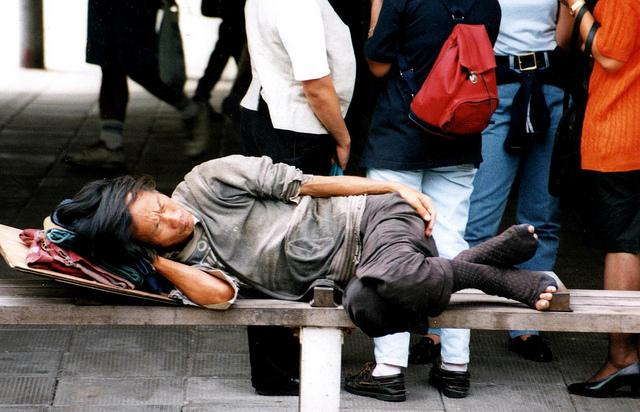Will anyone attempt to help this woman?
Be succinct. No. What is the woman attempting to do?
Give a very brief answer. Sleep. Does the woman have a home?
Write a very short answer. No. 